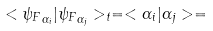Convert formula to latex. <formula><loc_0><loc_0><loc_500><loc_500>< { \psi _ { F } } _ { \alpha _ { i } } | { \psi _ { F } } _ { \alpha _ { j } } > _ { t } = < \alpha _ { i } | \alpha _ { j } > =</formula> 